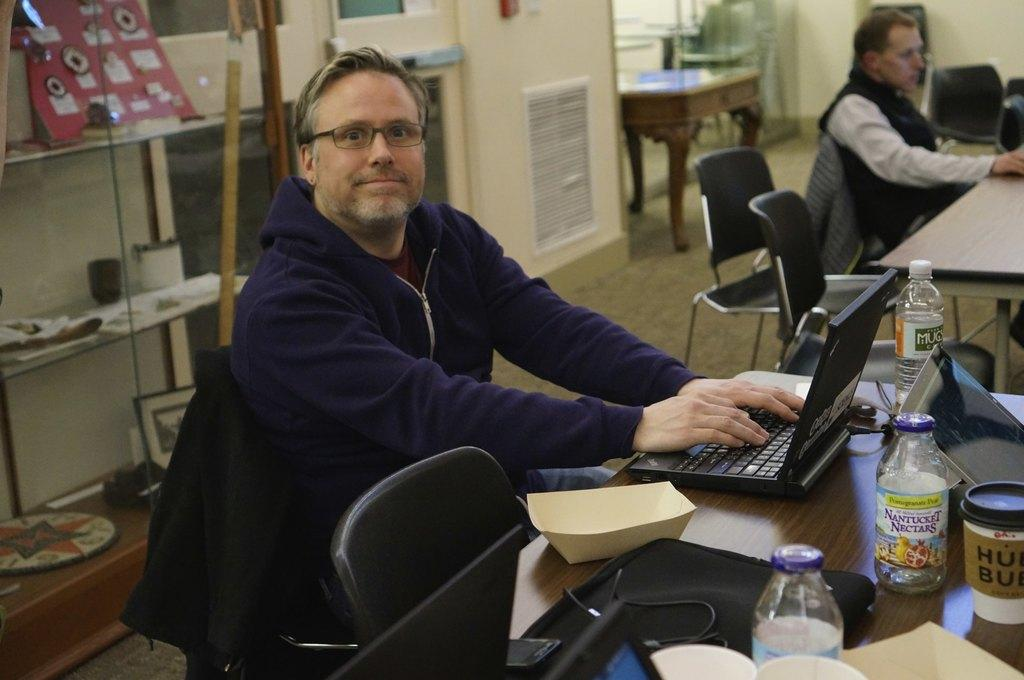What is the man in the image doing? The man is sitting on a chair in the image. What is in front of the chair? There is a table in front of the chair. What electronic device is on the table? A laptop is present on the table. What else can be seen on the table? There are other objects on the table. What is visible behind the man? There is a wall at the back of the scene. What type of boot is the man wearing in the image? The man is not wearing any boots in the image; he is sitting on a chair with his feet unseen. 